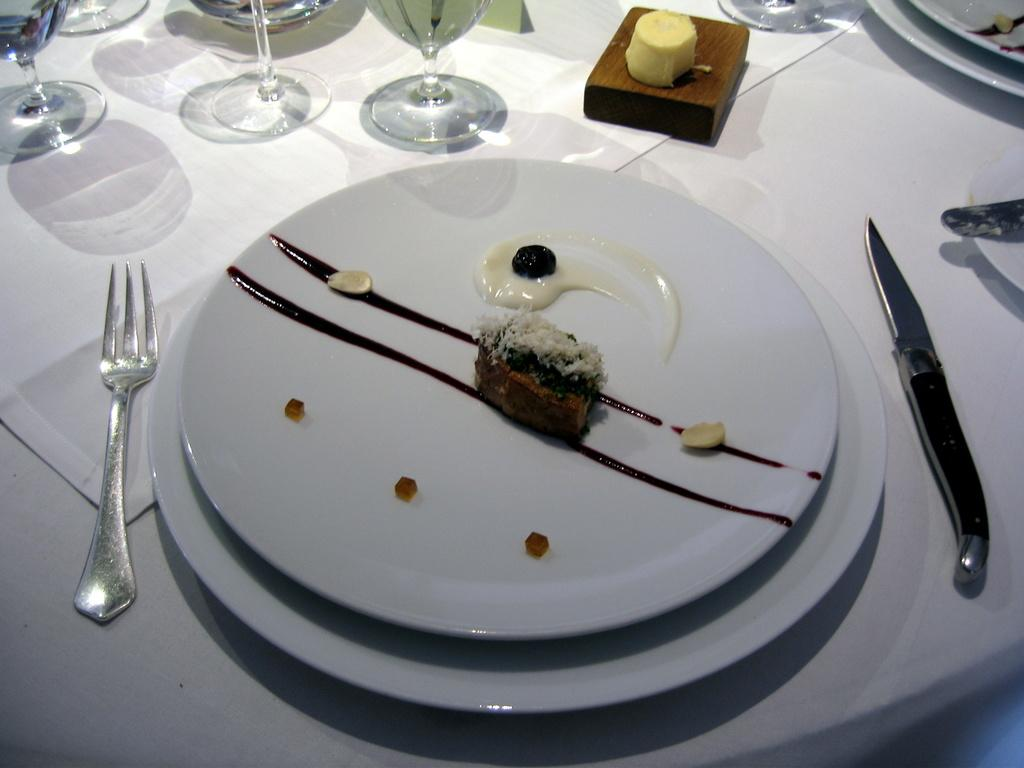What is covering the table in the image? The table is covered with a white cloth. What type of tableware can be seen on the table? There are glasses, forks, knives, and plates on the table. What else is present on the table besides tableware? There are other objects on the table. What type of food is visible on a plate in the image? There is a desert-like substance on a plate. Can you tell me how many planes are flying over the table in the image? There are no planes visible in the image; it only shows a table with various objects and food. What type of lead is used to create the forks and knives on the table? There is no information about the material used to create the forks and knives in the image, but they are likely made of metal, not lead. 